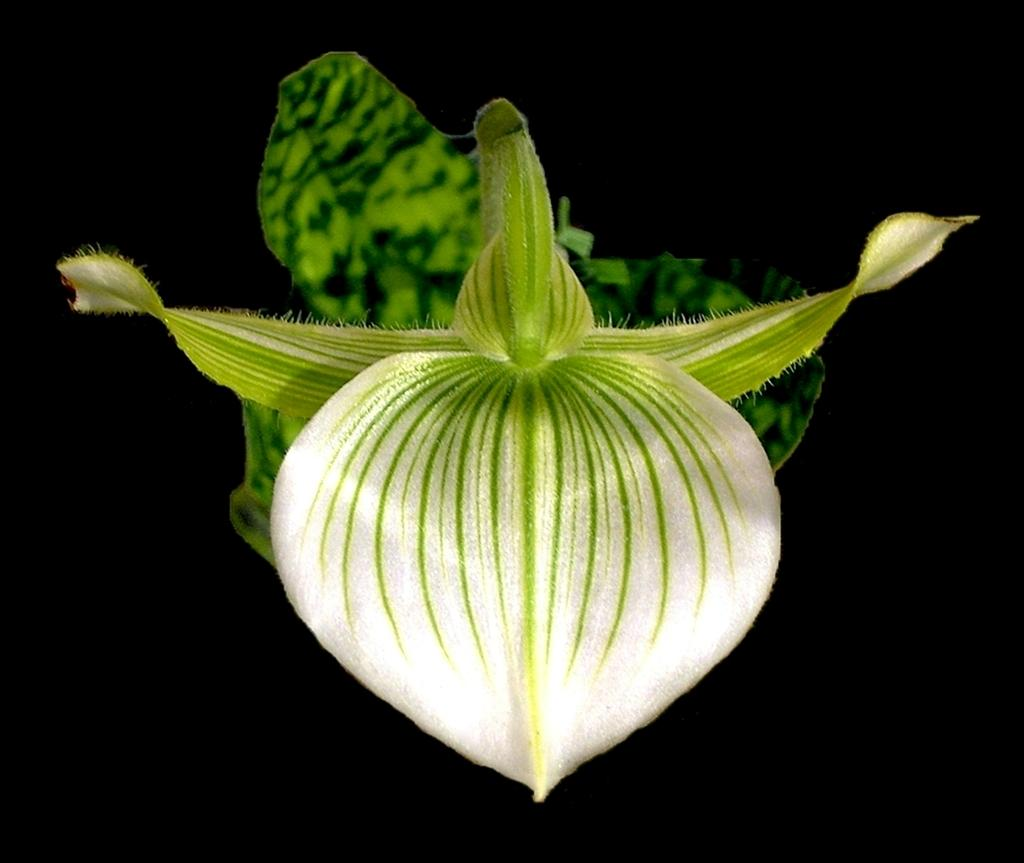What is the main subject of the image? The main subject of the image is a flower bud. What type of joke is being told by the fly in the image? There is no fly present in the image, and therefore no joke being told. 